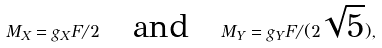Convert formula to latex. <formula><loc_0><loc_0><loc_500><loc_500>M _ { X } = g _ { X } F / 2 \quad \text {and} \quad M _ { Y } = g _ { Y } F / ( 2 \sqrt { 5 } ) ,</formula> 